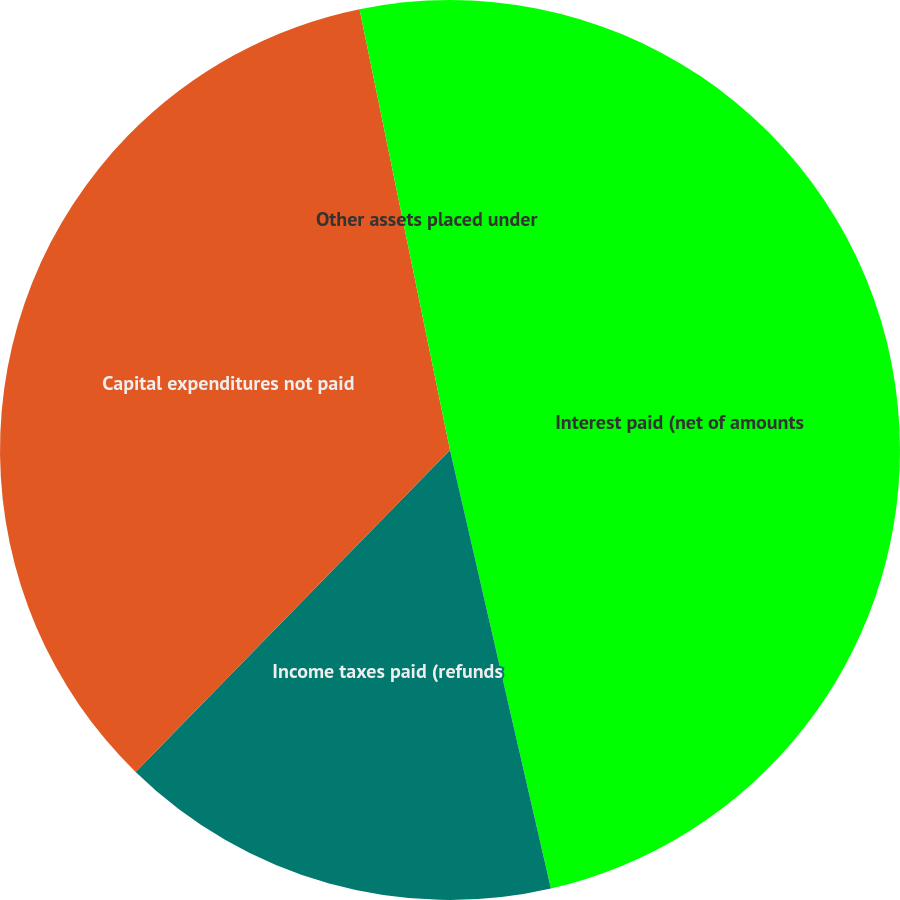Convert chart to OTSL. <chart><loc_0><loc_0><loc_500><loc_500><pie_chart><fcel>Interest paid (net of amounts<fcel>Income taxes paid (refunds<fcel>Capital expenditures not paid<fcel>Other assets placed under<nl><fcel>46.4%<fcel>15.91%<fcel>34.47%<fcel>3.22%<nl></chart> 